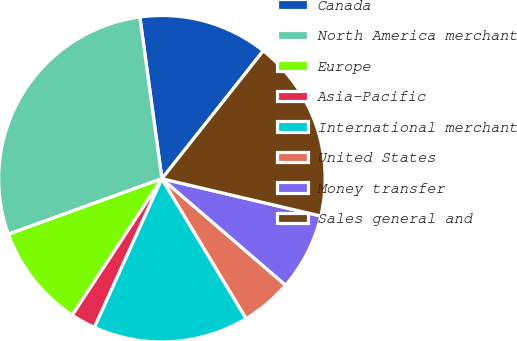Convert chart to OTSL. <chart><loc_0><loc_0><loc_500><loc_500><pie_chart><fcel>Canada<fcel>North America merchant<fcel>Europe<fcel>Asia-Pacific<fcel>International merchant<fcel>United States<fcel>Money transfer<fcel>Sales general and<nl><fcel>12.82%<fcel>28.36%<fcel>10.23%<fcel>2.47%<fcel>15.41%<fcel>5.06%<fcel>7.64%<fcel>18.0%<nl></chart> 